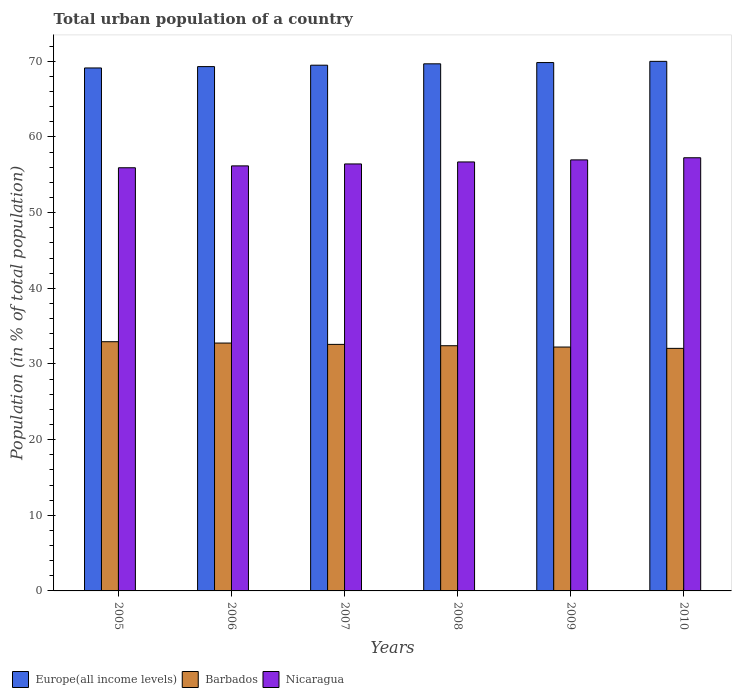Are the number of bars per tick equal to the number of legend labels?
Ensure brevity in your answer.  Yes. Are the number of bars on each tick of the X-axis equal?
Your response must be concise. Yes. What is the label of the 4th group of bars from the left?
Offer a very short reply. 2008. What is the urban population in Europe(all income levels) in 2006?
Make the answer very short. 69.3. Across all years, what is the maximum urban population in Europe(all income levels)?
Keep it short and to the point. 70. Across all years, what is the minimum urban population in Barbados?
Offer a very short reply. 32.06. In which year was the urban population in Nicaragua maximum?
Your answer should be compact. 2010. What is the total urban population in Europe(all income levels) in the graph?
Make the answer very short. 417.42. What is the difference between the urban population in Europe(all income levels) in 2006 and that in 2008?
Your answer should be compact. -0.37. What is the difference between the urban population in Europe(all income levels) in 2009 and the urban population in Barbados in 2006?
Keep it short and to the point. 37.08. What is the average urban population in Nicaragua per year?
Provide a succinct answer. 56.58. In the year 2010, what is the difference between the urban population in Barbados and urban population in Europe(all income levels)?
Make the answer very short. -37.94. In how many years, is the urban population in Barbados greater than 28 %?
Your answer should be compact. 6. What is the ratio of the urban population in Nicaragua in 2006 to that in 2007?
Offer a very short reply. 1. What is the difference between the highest and the second highest urban population in Barbados?
Keep it short and to the point. 0.18. What is the difference between the highest and the lowest urban population in Nicaragua?
Provide a short and direct response. 1.32. What does the 2nd bar from the left in 2006 represents?
Offer a terse response. Barbados. What does the 1st bar from the right in 2009 represents?
Make the answer very short. Nicaragua. How many bars are there?
Provide a short and direct response. 18. Are all the bars in the graph horizontal?
Offer a very short reply. No. How many years are there in the graph?
Make the answer very short. 6. What is the difference between two consecutive major ticks on the Y-axis?
Give a very brief answer. 10. Where does the legend appear in the graph?
Provide a succinct answer. Bottom left. How are the legend labels stacked?
Your answer should be compact. Horizontal. What is the title of the graph?
Make the answer very short. Total urban population of a country. What is the label or title of the X-axis?
Provide a succinct answer. Years. What is the label or title of the Y-axis?
Offer a very short reply. Population (in % of total population). What is the Population (in % of total population) of Europe(all income levels) in 2005?
Make the answer very short. 69.12. What is the Population (in % of total population) of Barbados in 2005?
Provide a short and direct response. 32.94. What is the Population (in % of total population) of Nicaragua in 2005?
Make the answer very short. 55.93. What is the Population (in % of total population) of Europe(all income levels) in 2006?
Provide a succinct answer. 69.3. What is the Population (in % of total population) in Barbados in 2006?
Ensure brevity in your answer.  32.76. What is the Population (in % of total population) of Nicaragua in 2006?
Your answer should be very brief. 56.18. What is the Population (in % of total population) of Europe(all income levels) in 2007?
Provide a short and direct response. 69.49. What is the Population (in % of total population) in Barbados in 2007?
Provide a short and direct response. 32.59. What is the Population (in % of total population) of Nicaragua in 2007?
Offer a very short reply. 56.44. What is the Population (in % of total population) of Europe(all income levels) in 2008?
Your answer should be compact. 69.67. What is the Population (in % of total population) of Barbados in 2008?
Make the answer very short. 32.41. What is the Population (in % of total population) in Nicaragua in 2008?
Your response must be concise. 56.7. What is the Population (in % of total population) of Europe(all income levels) in 2009?
Provide a short and direct response. 69.84. What is the Population (in % of total population) in Barbados in 2009?
Provide a succinct answer. 32.23. What is the Population (in % of total population) of Nicaragua in 2009?
Ensure brevity in your answer.  56.97. What is the Population (in % of total population) of Europe(all income levels) in 2010?
Make the answer very short. 70. What is the Population (in % of total population) in Barbados in 2010?
Your answer should be very brief. 32.06. What is the Population (in % of total population) in Nicaragua in 2010?
Your answer should be very brief. 57.26. Across all years, what is the maximum Population (in % of total population) in Europe(all income levels)?
Keep it short and to the point. 70. Across all years, what is the maximum Population (in % of total population) of Barbados?
Give a very brief answer. 32.94. Across all years, what is the maximum Population (in % of total population) in Nicaragua?
Provide a short and direct response. 57.26. Across all years, what is the minimum Population (in % of total population) in Europe(all income levels)?
Offer a very short reply. 69.12. Across all years, what is the minimum Population (in % of total population) in Barbados?
Provide a short and direct response. 32.06. Across all years, what is the minimum Population (in % of total population) of Nicaragua?
Ensure brevity in your answer.  55.93. What is the total Population (in % of total population) of Europe(all income levels) in the graph?
Offer a terse response. 417.42. What is the total Population (in % of total population) of Barbados in the graph?
Keep it short and to the point. 194.99. What is the total Population (in % of total population) of Nicaragua in the graph?
Keep it short and to the point. 339.48. What is the difference between the Population (in % of total population) of Europe(all income levels) in 2005 and that in 2006?
Your answer should be very brief. -0.18. What is the difference between the Population (in % of total population) in Barbados in 2005 and that in 2006?
Provide a short and direct response. 0.18. What is the difference between the Population (in % of total population) of Nicaragua in 2005 and that in 2006?
Keep it short and to the point. -0.25. What is the difference between the Population (in % of total population) of Europe(all income levels) in 2005 and that in 2007?
Your response must be concise. -0.36. What is the difference between the Population (in % of total population) of Barbados in 2005 and that in 2007?
Keep it short and to the point. 0.35. What is the difference between the Population (in % of total population) in Nicaragua in 2005 and that in 2007?
Your response must be concise. -0.5. What is the difference between the Population (in % of total population) of Europe(all income levels) in 2005 and that in 2008?
Offer a terse response. -0.55. What is the difference between the Population (in % of total population) in Barbados in 2005 and that in 2008?
Keep it short and to the point. 0.53. What is the difference between the Population (in % of total population) in Nicaragua in 2005 and that in 2008?
Your answer should be compact. -0.77. What is the difference between the Population (in % of total population) of Europe(all income levels) in 2005 and that in 2009?
Your response must be concise. -0.71. What is the difference between the Population (in % of total population) in Barbados in 2005 and that in 2009?
Give a very brief answer. 0.7. What is the difference between the Population (in % of total population) of Nicaragua in 2005 and that in 2009?
Your answer should be very brief. -1.04. What is the difference between the Population (in % of total population) of Europe(all income levels) in 2005 and that in 2010?
Your response must be concise. -0.87. What is the difference between the Population (in % of total population) of Barbados in 2005 and that in 2010?
Make the answer very short. 0.88. What is the difference between the Population (in % of total population) of Nicaragua in 2005 and that in 2010?
Your answer should be very brief. -1.32. What is the difference between the Population (in % of total population) in Europe(all income levels) in 2006 and that in 2007?
Provide a succinct answer. -0.19. What is the difference between the Population (in % of total population) of Barbados in 2006 and that in 2007?
Keep it short and to the point. 0.18. What is the difference between the Population (in % of total population) of Nicaragua in 2006 and that in 2007?
Offer a very short reply. -0.26. What is the difference between the Population (in % of total population) of Europe(all income levels) in 2006 and that in 2008?
Make the answer very short. -0.37. What is the difference between the Population (in % of total population) of Barbados in 2006 and that in 2008?
Provide a short and direct response. 0.35. What is the difference between the Population (in % of total population) in Nicaragua in 2006 and that in 2008?
Ensure brevity in your answer.  -0.52. What is the difference between the Population (in % of total population) in Europe(all income levels) in 2006 and that in 2009?
Provide a succinct answer. -0.53. What is the difference between the Population (in % of total population) of Barbados in 2006 and that in 2009?
Give a very brief answer. 0.53. What is the difference between the Population (in % of total population) of Nicaragua in 2006 and that in 2009?
Keep it short and to the point. -0.79. What is the difference between the Population (in % of total population) of Europe(all income levels) in 2006 and that in 2010?
Your answer should be compact. -0.69. What is the difference between the Population (in % of total population) in Barbados in 2006 and that in 2010?
Give a very brief answer. 0.7. What is the difference between the Population (in % of total population) in Nicaragua in 2006 and that in 2010?
Ensure brevity in your answer.  -1.07. What is the difference between the Population (in % of total population) in Europe(all income levels) in 2007 and that in 2008?
Give a very brief answer. -0.18. What is the difference between the Population (in % of total population) of Barbados in 2007 and that in 2008?
Keep it short and to the point. 0.18. What is the difference between the Population (in % of total population) in Nicaragua in 2007 and that in 2008?
Offer a very short reply. -0.26. What is the difference between the Population (in % of total population) in Europe(all income levels) in 2007 and that in 2009?
Ensure brevity in your answer.  -0.35. What is the difference between the Population (in % of total population) of Barbados in 2007 and that in 2009?
Your answer should be very brief. 0.35. What is the difference between the Population (in % of total population) in Nicaragua in 2007 and that in 2009?
Ensure brevity in your answer.  -0.54. What is the difference between the Population (in % of total population) of Europe(all income levels) in 2007 and that in 2010?
Keep it short and to the point. -0.51. What is the difference between the Population (in % of total population) in Barbados in 2007 and that in 2010?
Your response must be concise. 0.53. What is the difference between the Population (in % of total population) of Nicaragua in 2007 and that in 2010?
Make the answer very short. -0.82. What is the difference between the Population (in % of total population) of Europe(all income levels) in 2008 and that in 2009?
Give a very brief answer. -0.17. What is the difference between the Population (in % of total population) in Barbados in 2008 and that in 2009?
Your response must be concise. 0.17. What is the difference between the Population (in % of total population) in Nicaragua in 2008 and that in 2009?
Make the answer very short. -0.27. What is the difference between the Population (in % of total population) of Europe(all income levels) in 2008 and that in 2010?
Offer a very short reply. -0.33. What is the difference between the Population (in % of total population) in Nicaragua in 2008 and that in 2010?
Offer a very short reply. -0.55. What is the difference between the Population (in % of total population) of Europe(all income levels) in 2009 and that in 2010?
Offer a terse response. -0.16. What is the difference between the Population (in % of total population) of Barbados in 2009 and that in 2010?
Provide a succinct answer. 0.17. What is the difference between the Population (in % of total population) of Nicaragua in 2009 and that in 2010?
Provide a succinct answer. -0.28. What is the difference between the Population (in % of total population) in Europe(all income levels) in 2005 and the Population (in % of total population) in Barbados in 2006?
Your answer should be compact. 36.36. What is the difference between the Population (in % of total population) of Europe(all income levels) in 2005 and the Population (in % of total population) of Nicaragua in 2006?
Provide a short and direct response. 12.94. What is the difference between the Population (in % of total population) in Barbados in 2005 and the Population (in % of total population) in Nicaragua in 2006?
Your answer should be compact. -23.24. What is the difference between the Population (in % of total population) of Europe(all income levels) in 2005 and the Population (in % of total population) of Barbados in 2007?
Your answer should be compact. 36.54. What is the difference between the Population (in % of total population) in Europe(all income levels) in 2005 and the Population (in % of total population) in Nicaragua in 2007?
Your answer should be very brief. 12.69. What is the difference between the Population (in % of total population) of Barbados in 2005 and the Population (in % of total population) of Nicaragua in 2007?
Keep it short and to the point. -23.5. What is the difference between the Population (in % of total population) of Europe(all income levels) in 2005 and the Population (in % of total population) of Barbados in 2008?
Keep it short and to the point. 36.71. What is the difference between the Population (in % of total population) in Europe(all income levels) in 2005 and the Population (in % of total population) in Nicaragua in 2008?
Ensure brevity in your answer.  12.42. What is the difference between the Population (in % of total population) in Barbados in 2005 and the Population (in % of total population) in Nicaragua in 2008?
Your answer should be very brief. -23.76. What is the difference between the Population (in % of total population) in Europe(all income levels) in 2005 and the Population (in % of total population) in Barbados in 2009?
Provide a succinct answer. 36.89. What is the difference between the Population (in % of total population) of Europe(all income levels) in 2005 and the Population (in % of total population) of Nicaragua in 2009?
Keep it short and to the point. 12.15. What is the difference between the Population (in % of total population) of Barbados in 2005 and the Population (in % of total population) of Nicaragua in 2009?
Your response must be concise. -24.04. What is the difference between the Population (in % of total population) in Europe(all income levels) in 2005 and the Population (in % of total population) in Barbados in 2010?
Offer a very short reply. 37.06. What is the difference between the Population (in % of total population) of Europe(all income levels) in 2005 and the Population (in % of total population) of Nicaragua in 2010?
Offer a terse response. 11.87. What is the difference between the Population (in % of total population) in Barbados in 2005 and the Population (in % of total population) in Nicaragua in 2010?
Your response must be concise. -24.32. What is the difference between the Population (in % of total population) in Europe(all income levels) in 2006 and the Population (in % of total population) in Barbados in 2007?
Your answer should be very brief. 36.72. What is the difference between the Population (in % of total population) in Europe(all income levels) in 2006 and the Population (in % of total population) in Nicaragua in 2007?
Make the answer very short. 12.87. What is the difference between the Population (in % of total population) in Barbados in 2006 and the Population (in % of total population) in Nicaragua in 2007?
Provide a succinct answer. -23.68. What is the difference between the Population (in % of total population) of Europe(all income levels) in 2006 and the Population (in % of total population) of Barbados in 2008?
Keep it short and to the point. 36.89. What is the difference between the Population (in % of total population) of Europe(all income levels) in 2006 and the Population (in % of total population) of Nicaragua in 2008?
Give a very brief answer. 12.6. What is the difference between the Population (in % of total population) of Barbados in 2006 and the Population (in % of total population) of Nicaragua in 2008?
Make the answer very short. -23.94. What is the difference between the Population (in % of total population) in Europe(all income levels) in 2006 and the Population (in % of total population) in Barbados in 2009?
Offer a very short reply. 37.07. What is the difference between the Population (in % of total population) in Europe(all income levels) in 2006 and the Population (in % of total population) in Nicaragua in 2009?
Your response must be concise. 12.33. What is the difference between the Population (in % of total population) of Barbados in 2006 and the Population (in % of total population) of Nicaragua in 2009?
Your response must be concise. -24.21. What is the difference between the Population (in % of total population) of Europe(all income levels) in 2006 and the Population (in % of total population) of Barbados in 2010?
Offer a terse response. 37.24. What is the difference between the Population (in % of total population) of Europe(all income levels) in 2006 and the Population (in % of total population) of Nicaragua in 2010?
Offer a very short reply. 12.05. What is the difference between the Population (in % of total population) of Barbados in 2006 and the Population (in % of total population) of Nicaragua in 2010?
Give a very brief answer. -24.49. What is the difference between the Population (in % of total population) in Europe(all income levels) in 2007 and the Population (in % of total population) in Barbados in 2008?
Provide a short and direct response. 37.08. What is the difference between the Population (in % of total population) in Europe(all income levels) in 2007 and the Population (in % of total population) in Nicaragua in 2008?
Make the answer very short. 12.79. What is the difference between the Population (in % of total population) in Barbados in 2007 and the Population (in % of total population) in Nicaragua in 2008?
Ensure brevity in your answer.  -24.11. What is the difference between the Population (in % of total population) in Europe(all income levels) in 2007 and the Population (in % of total population) in Barbados in 2009?
Provide a succinct answer. 37.25. What is the difference between the Population (in % of total population) in Europe(all income levels) in 2007 and the Population (in % of total population) in Nicaragua in 2009?
Give a very brief answer. 12.52. What is the difference between the Population (in % of total population) in Barbados in 2007 and the Population (in % of total population) in Nicaragua in 2009?
Give a very brief answer. -24.39. What is the difference between the Population (in % of total population) in Europe(all income levels) in 2007 and the Population (in % of total population) in Barbados in 2010?
Offer a terse response. 37.43. What is the difference between the Population (in % of total population) of Europe(all income levels) in 2007 and the Population (in % of total population) of Nicaragua in 2010?
Provide a succinct answer. 12.23. What is the difference between the Population (in % of total population) in Barbados in 2007 and the Population (in % of total population) in Nicaragua in 2010?
Make the answer very short. -24.67. What is the difference between the Population (in % of total population) of Europe(all income levels) in 2008 and the Population (in % of total population) of Barbados in 2009?
Provide a short and direct response. 37.44. What is the difference between the Population (in % of total population) of Europe(all income levels) in 2008 and the Population (in % of total population) of Nicaragua in 2009?
Keep it short and to the point. 12.7. What is the difference between the Population (in % of total population) of Barbados in 2008 and the Population (in % of total population) of Nicaragua in 2009?
Your response must be concise. -24.56. What is the difference between the Population (in % of total population) in Europe(all income levels) in 2008 and the Population (in % of total population) in Barbados in 2010?
Ensure brevity in your answer.  37.61. What is the difference between the Population (in % of total population) of Europe(all income levels) in 2008 and the Population (in % of total population) of Nicaragua in 2010?
Provide a short and direct response. 12.42. What is the difference between the Population (in % of total population) of Barbados in 2008 and the Population (in % of total population) of Nicaragua in 2010?
Your answer should be very brief. -24.84. What is the difference between the Population (in % of total population) of Europe(all income levels) in 2009 and the Population (in % of total population) of Barbados in 2010?
Provide a succinct answer. 37.78. What is the difference between the Population (in % of total population) of Europe(all income levels) in 2009 and the Population (in % of total population) of Nicaragua in 2010?
Offer a terse response. 12.58. What is the difference between the Population (in % of total population) in Barbados in 2009 and the Population (in % of total population) in Nicaragua in 2010?
Keep it short and to the point. -25.02. What is the average Population (in % of total population) in Europe(all income levels) per year?
Your answer should be compact. 69.57. What is the average Population (in % of total population) in Barbados per year?
Give a very brief answer. 32.5. What is the average Population (in % of total population) of Nicaragua per year?
Keep it short and to the point. 56.58. In the year 2005, what is the difference between the Population (in % of total population) in Europe(all income levels) and Population (in % of total population) in Barbados?
Ensure brevity in your answer.  36.19. In the year 2005, what is the difference between the Population (in % of total population) in Europe(all income levels) and Population (in % of total population) in Nicaragua?
Offer a terse response. 13.19. In the year 2005, what is the difference between the Population (in % of total population) in Barbados and Population (in % of total population) in Nicaragua?
Your answer should be compact. -22.99. In the year 2006, what is the difference between the Population (in % of total population) of Europe(all income levels) and Population (in % of total population) of Barbados?
Provide a short and direct response. 36.54. In the year 2006, what is the difference between the Population (in % of total population) in Europe(all income levels) and Population (in % of total population) in Nicaragua?
Make the answer very short. 13.12. In the year 2006, what is the difference between the Population (in % of total population) of Barbados and Population (in % of total population) of Nicaragua?
Provide a short and direct response. -23.42. In the year 2007, what is the difference between the Population (in % of total population) in Europe(all income levels) and Population (in % of total population) in Barbados?
Your answer should be very brief. 36.9. In the year 2007, what is the difference between the Population (in % of total population) in Europe(all income levels) and Population (in % of total population) in Nicaragua?
Keep it short and to the point. 13.05. In the year 2007, what is the difference between the Population (in % of total population) in Barbados and Population (in % of total population) in Nicaragua?
Your response must be concise. -23.85. In the year 2008, what is the difference between the Population (in % of total population) in Europe(all income levels) and Population (in % of total population) in Barbados?
Your answer should be compact. 37.26. In the year 2008, what is the difference between the Population (in % of total population) of Europe(all income levels) and Population (in % of total population) of Nicaragua?
Offer a terse response. 12.97. In the year 2008, what is the difference between the Population (in % of total population) of Barbados and Population (in % of total population) of Nicaragua?
Provide a short and direct response. -24.29. In the year 2009, what is the difference between the Population (in % of total population) of Europe(all income levels) and Population (in % of total population) of Barbados?
Keep it short and to the point. 37.6. In the year 2009, what is the difference between the Population (in % of total population) in Europe(all income levels) and Population (in % of total population) in Nicaragua?
Your answer should be very brief. 12.86. In the year 2009, what is the difference between the Population (in % of total population) of Barbados and Population (in % of total population) of Nicaragua?
Your answer should be very brief. -24.74. In the year 2010, what is the difference between the Population (in % of total population) in Europe(all income levels) and Population (in % of total population) in Barbados?
Give a very brief answer. 37.94. In the year 2010, what is the difference between the Population (in % of total population) in Europe(all income levels) and Population (in % of total population) in Nicaragua?
Offer a terse response. 12.74. In the year 2010, what is the difference between the Population (in % of total population) of Barbados and Population (in % of total population) of Nicaragua?
Keep it short and to the point. -25.2. What is the ratio of the Population (in % of total population) of Barbados in 2005 to that in 2006?
Provide a short and direct response. 1.01. What is the ratio of the Population (in % of total population) of Nicaragua in 2005 to that in 2006?
Ensure brevity in your answer.  1. What is the ratio of the Population (in % of total population) in Europe(all income levels) in 2005 to that in 2007?
Provide a short and direct response. 0.99. What is the ratio of the Population (in % of total population) of Barbados in 2005 to that in 2007?
Offer a very short reply. 1.01. What is the ratio of the Population (in % of total population) in Barbados in 2005 to that in 2008?
Ensure brevity in your answer.  1.02. What is the ratio of the Population (in % of total population) in Nicaragua in 2005 to that in 2008?
Your response must be concise. 0.99. What is the ratio of the Population (in % of total population) in Barbados in 2005 to that in 2009?
Give a very brief answer. 1.02. What is the ratio of the Population (in % of total population) of Nicaragua in 2005 to that in 2009?
Give a very brief answer. 0.98. What is the ratio of the Population (in % of total population) of Europe(all income levels) in 2005 to that in 2010?
Give a very brief answer. 0.99. What is the ratio of the Population (in % of total population) in Barbados in 2005 to that in 2010?
Provide a short and direct response. 1.03. What is the ratio of the Population (in % of total population) of Nicaragua in 2005 to that in 2010?
Provide a short and direct response. 0.98. What is the ratio of the Population (in % of total population) in Europe(all income levels) in 2006 to that in 2007?
Ensure brevity in your answer.  1. What is the ratio of the Population (in % of total population) in Barbados in 2006 to that in 2007?
Make the answer very short. 1.01. What is the ratio of the Population (in % of total population) of Nicaragua in 2006 to that in 2007?
Your response must be concise. 1. What is the ratio of the Population (in % of total population) of Europe(all income levels) in 2006 to that in 2008?
Your answer should be compact. 0.99. What is the ratio of the Population (in % of total population) of Barbados in 2006 to that in 2008?
Your response must be concise. 1.01. What is the ratio of the Population (in % of total population) of Nicaragua in 2006 to that in 2008?
Your response must be concise. 0.99. What is the ratio of the Population (in % of total population) of Europe(all income levels) in 2006 to that in 2009?
Offer a very short reply. 0.99. What is the ratio of the Population (in % of total population) of Barbados in 2006 to that in 2009?
Your answer should be compact. 1.02. What is the ratio of the Population (in % of total population) in Nicaragua in 2006 to that in 2009?
Offer a terse response. 0.99. What is the ratio of the Population (in % of total population) in Europe(all income levels) in 2006 to that in 2010?
Offer a very short reply. 0.99. What is the ratio of the Population (in % of total population) in Barbados in 2006 to that in 2010?
Offer a terse response. 1.02. What is the ratio of the Population (in % of total population) in Nicaragua in 2006 to that in 2010?
Offer a very short reply. 0.98. What is the ratio of the Population (in % of total population) of Europe(all income levels) in 2007 to that in 2008?
Your answer should be very brief. 1. What is the ratio of the Population (in % of total population) of Barbados in 2007 to that in 2008?
Keep it short and to the point. 1.01. What is the ratio of the Population (in % of total population) of Nicaragua in 2007 to that in 2008?
Provide a short and direct response. 1. What is the ratio of the Population (in % of total population) of Europe(all income levels) in 2007 to that in 2009?
Keep it short and to the point. 0.99. What is the ratio of the Population (in % of total population) in Barbados in 2007 to that in 2009?
Make the answer very short. 1.01. What is the ratio of the Population (in % of total population) in Nicaragua in 2007 to that in 2009?
Your answer should be compact. 0.99. What is the ratio of the Population (in % of total population) of Barbados in 2007 to that in 2010?
Keep it short and to the point. 1.02. What is the ratio of the Population (in % of total population) of Nicaragua in 2007 to that in 2010?
Offer a very short reply. 0.99. What is the ratio of the Population (in % of total population) in Barbados in 2008 to that in 2009?
Your response must be concise. 1.01. What is the ratio of the Population (in % of total population) of Barbados in 2008 to that in 2010?
Make the answer very short. 1.01. What is the ratio of the Population (in % of total population) in Nicaragua in 2008 to that in 2010?
Keep it short and to the point. 0.99. What is the ratio of the Population (in % of total population) of Barbados in 2009 to that in 2010?
Offer a terse response. 1.01. What is the ratio of the Population (in % of total population) of Nicaragua in 2009 to that in 2010?
Make the answer very short. 1. What is the difference between the highest and the second highest Population (in % of total population) in Europe(all income levels)?
Your answer should be compact. 0.16. What is the difference between the highest and the second highest Population (in % of total population) in Barbados?
Make the answer very short. 0.18. What is the difference between the highest and the second highest Population (in % of total population) of Nicaragua?
Offer a terse response. 0.28. What is the difference between the highest and the lowest Population (in % of total population) of Europe(all income levels)?
Offer a very short reply. 0.87. What is the difference between the highest and the lowest Population (in % of total population) of Barbados?
Make the answer very short. 0.88. What is the difference between the highest and the lowest Population (in % of total population) of Nicaragua?
Your response must be concise. 1.32. 